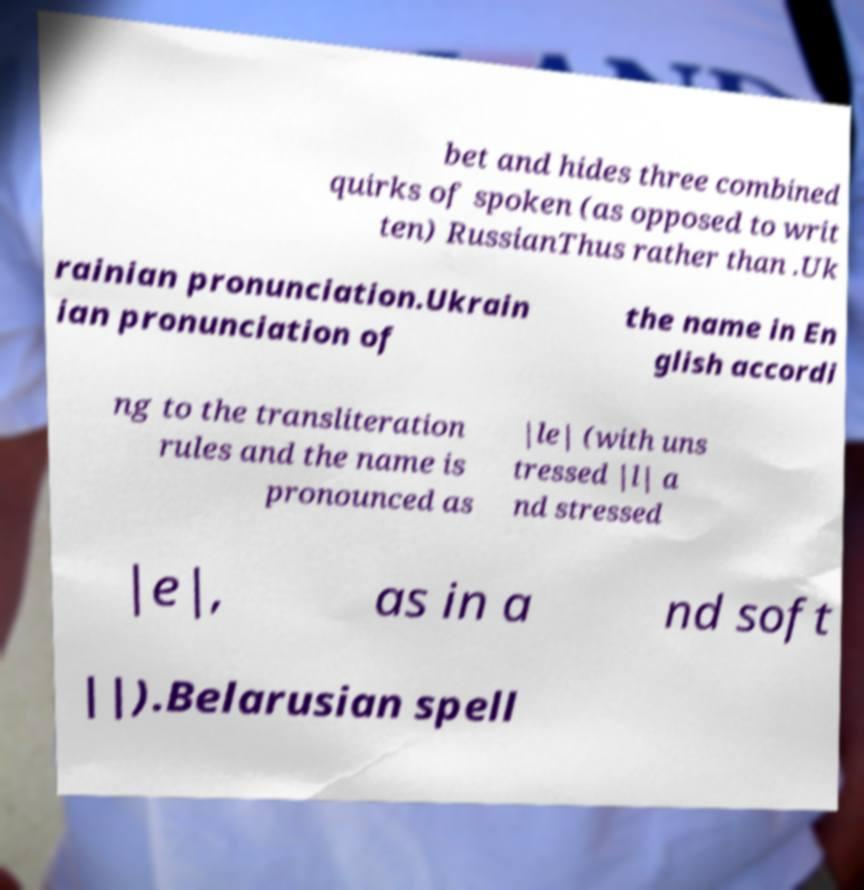Please identify and transcribe the text found in this image. bet and hides three combined quirks of spoken (as opposed to writ ten) RussianThus rather than .Uk rainian pronunciation.Ukrain ian pronunciation of the name in En glish accordi ng to the transliteration rules and the name is pronounced as |le| (with uns tressed |l| a nd stressed |e|, as in a nd soft ||).Belarusian spell 